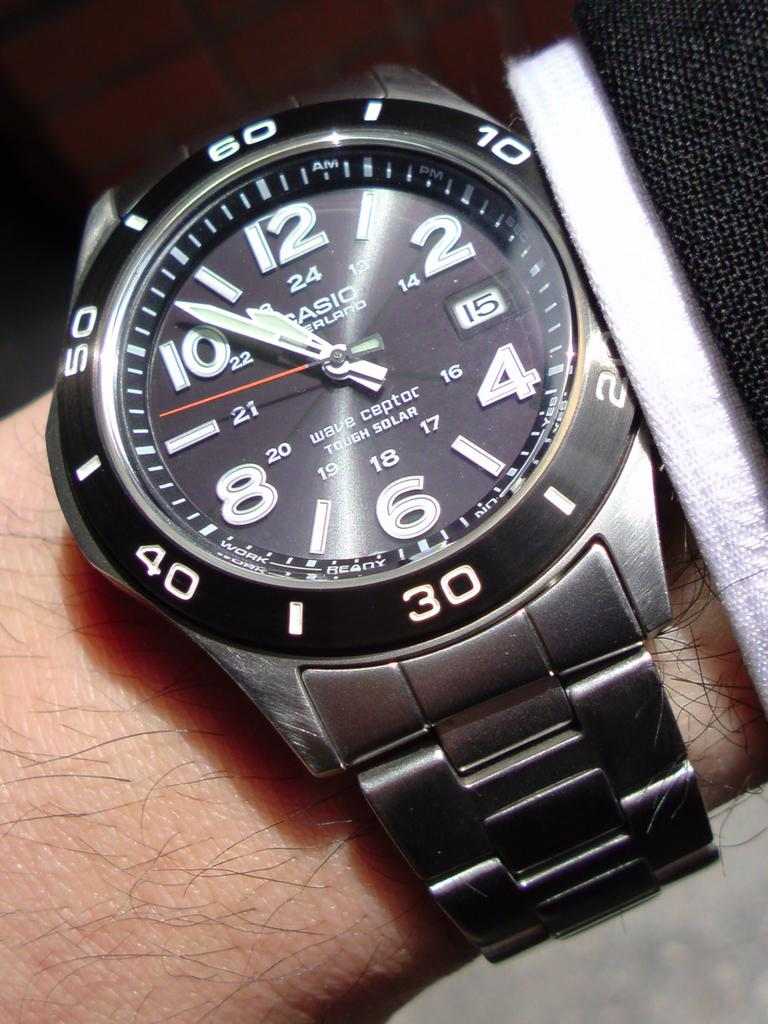<image>
Describe the image concisely. A Casio watch shows that the time is now 10:53. 